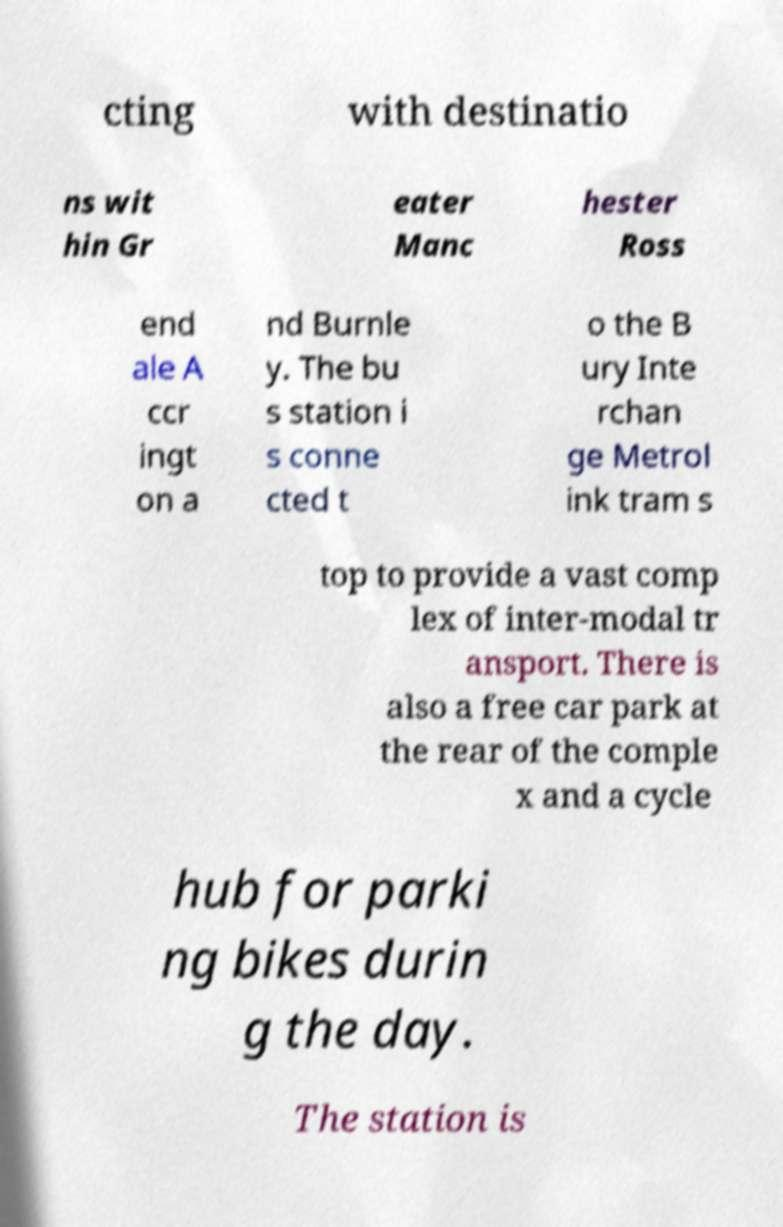Could you assist in decoding the text presented in this image and type it out clearly? cting with destinatio ns wit hin Gr eater Manc hester Ross end ale A ccr ingt on a nd Burnle y. The bu s station i s conne cted t o the B ury Inte rchan ge Metrol ink tram s top to provide a vast comp lex of inter-modal tr ansport. There is also a free car park at the rear of the comple x and a cycle hub for parki ng bikes durin g the day. The station is 